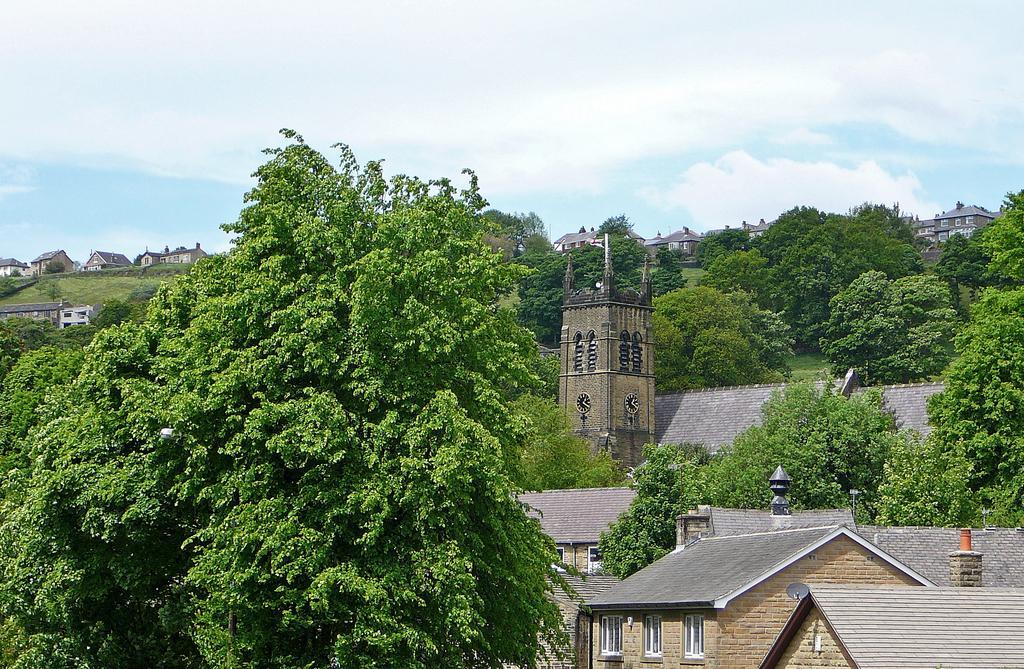Could you give a brief overview of what you see in this image? In the picture I can see some houses and trees. 